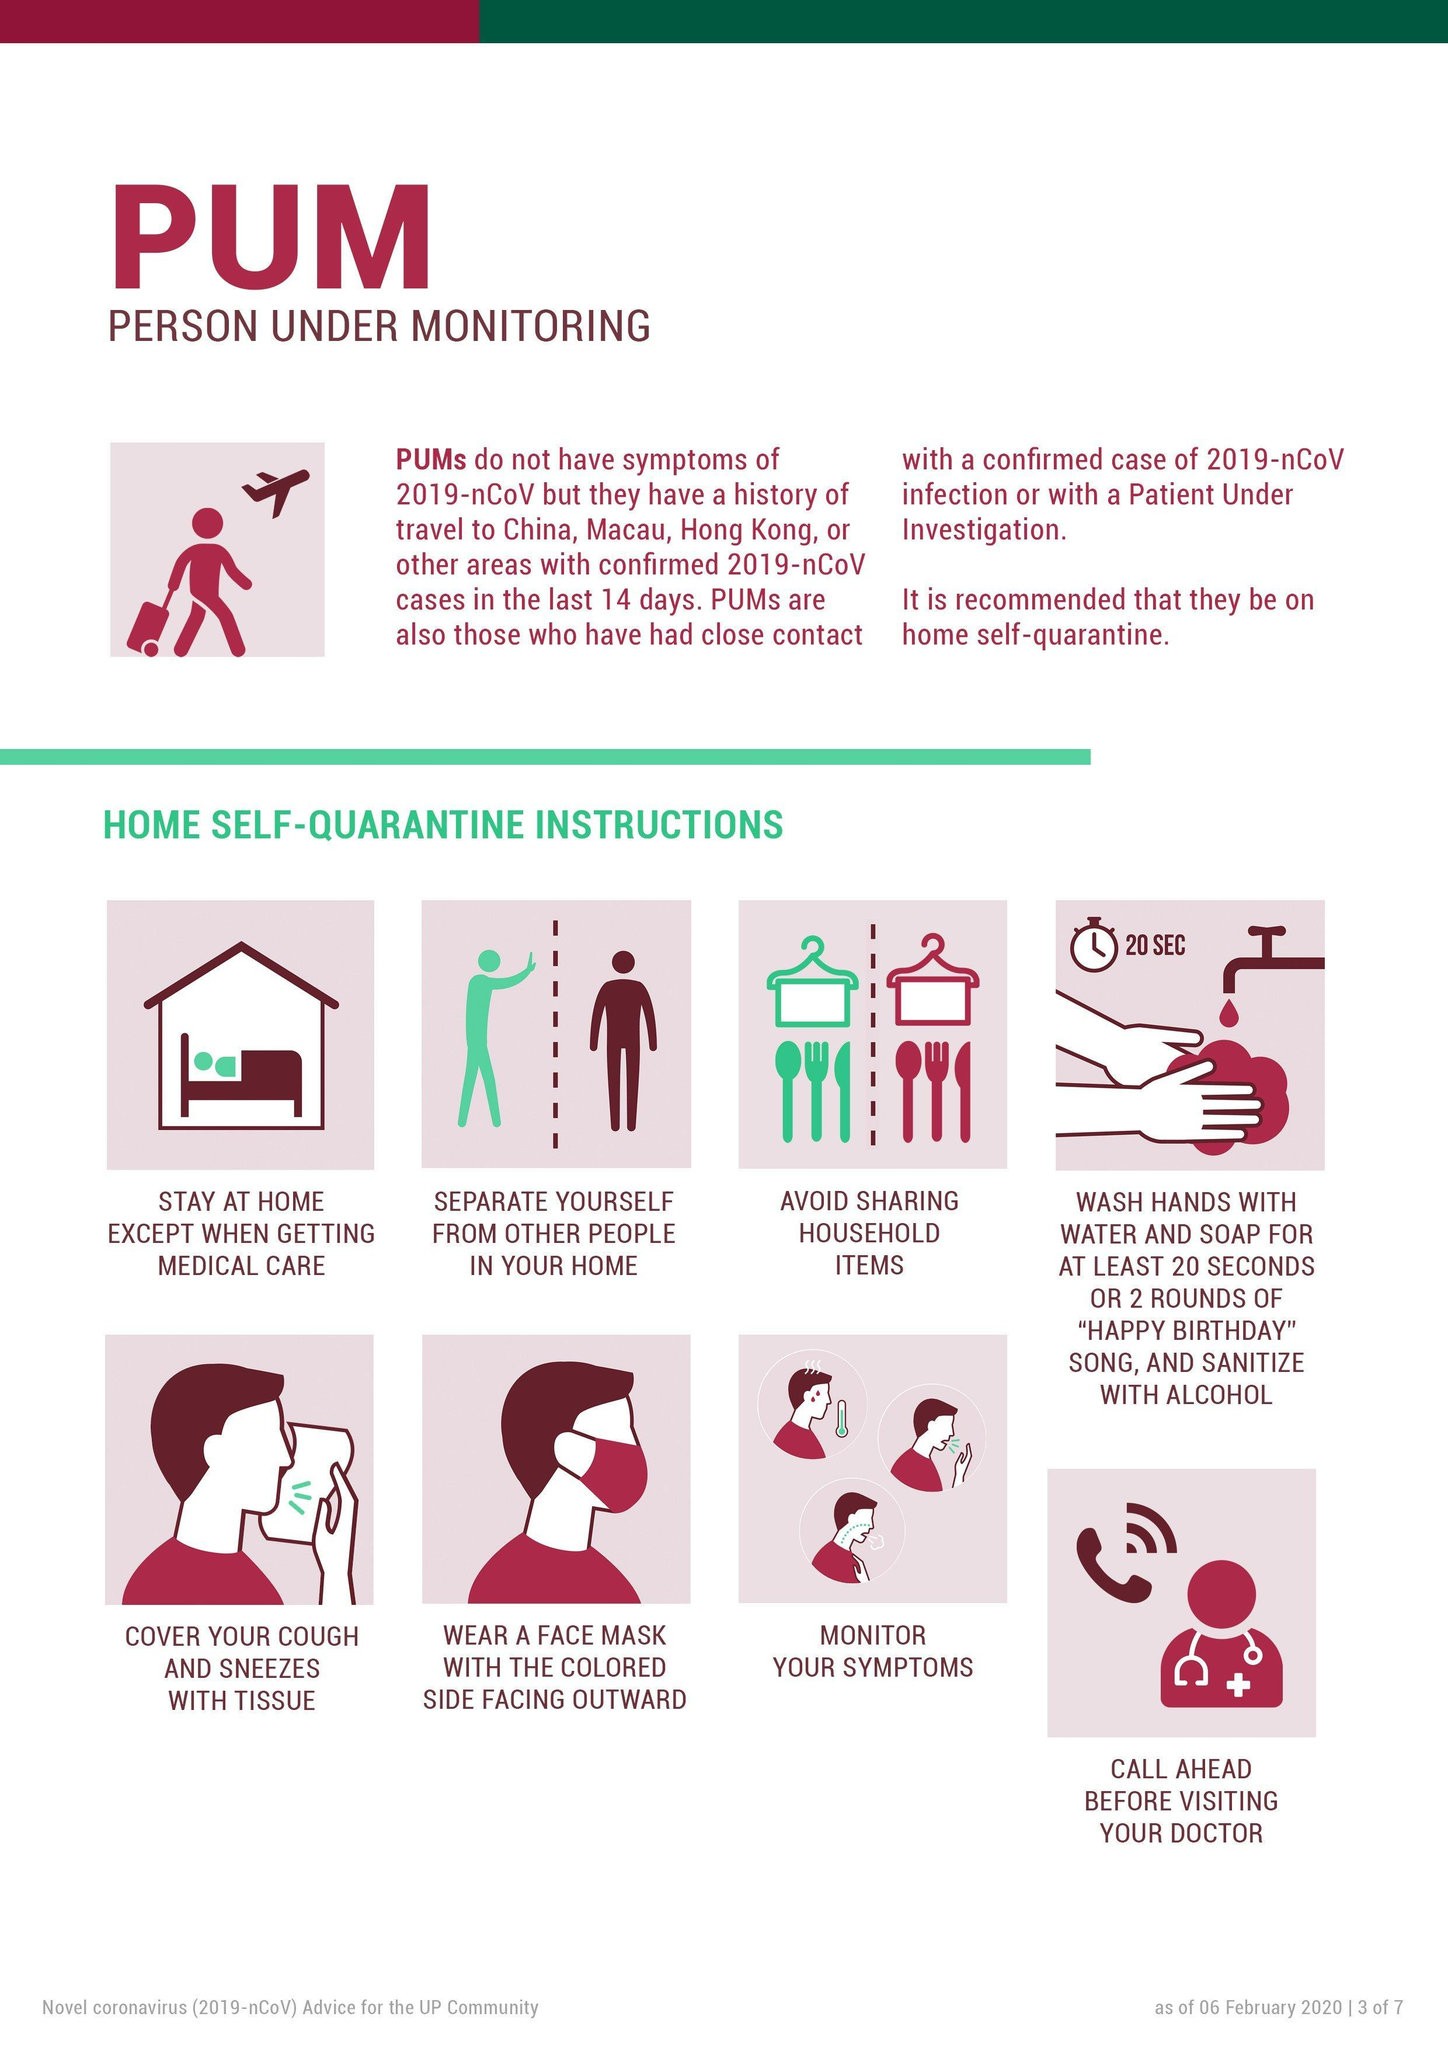How long one should wash their hands in order to prevent the spread of COVID-19?
Answer the question with a short phrase. 20 SEC 